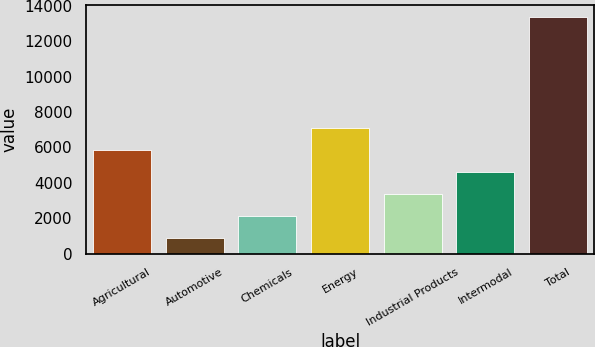Convert chart to OTSL. <chart><loc_0><loc_0><loc_500><loc_500><bar_chart><fcel>Agricultural<fcel>Automotive<fcel>Chemicals<fcel>Energy<fcel>Industrial Products<fcel>Intermodal<fcel>Total<nl><fcel>5861.6<fcel>854<fcel>2105.9<fcel>7113.5<fcel>3357.8<fcel>4609.7<fcel>13373<nl></chart> 